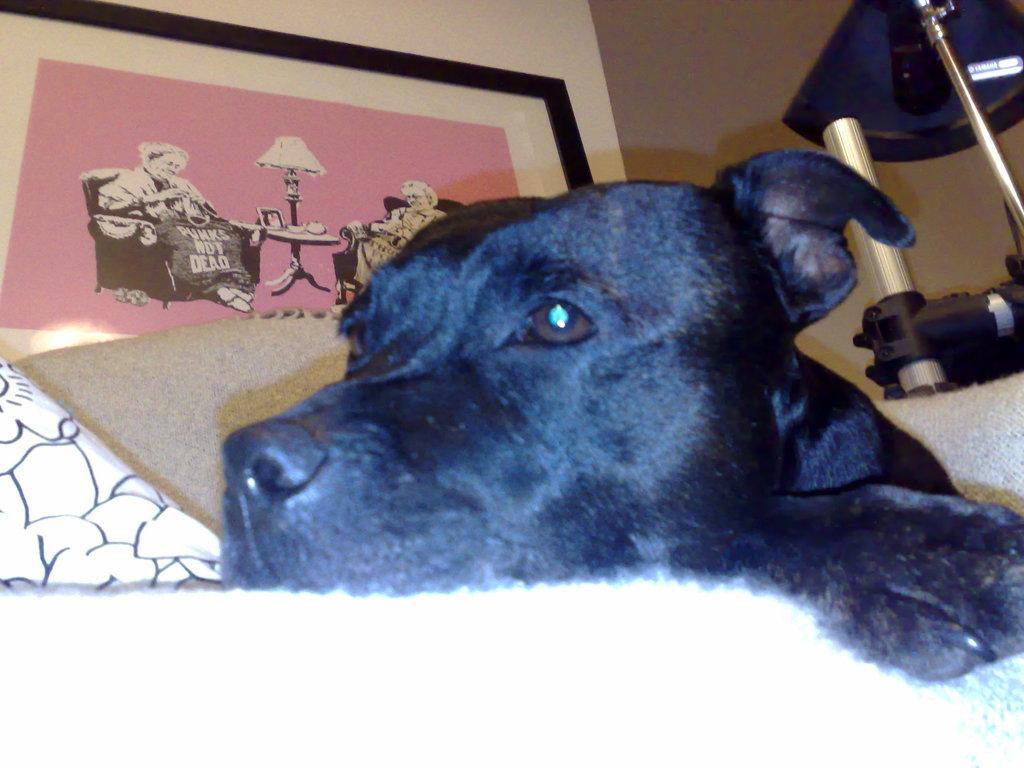In one or two sentences, can you explain what this image depicts? In this picture we observe a black dog sleeping on the bed. 